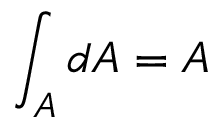<formula> <loc_0><loc_0><loc_500><loc_500>\int _ { A } d A = A</formula> 